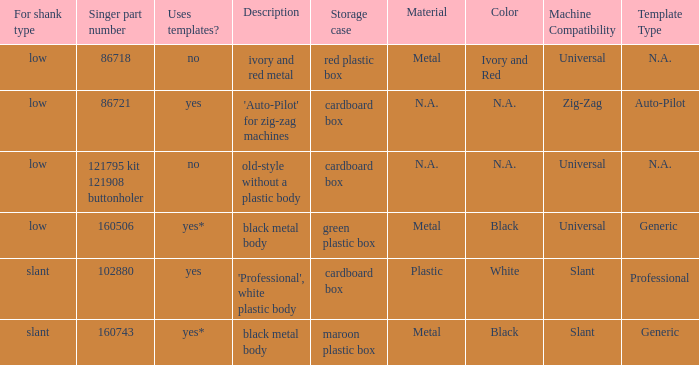What's the storage case of the buttonholer described as ivory and red metal? Red plastic box. 